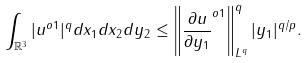Convert formula to latex. <formula><loc_0><loc_0><loc_500><loc_500>\int _ { \mathbb { R } ^ { 3 } } | u ^ { o 1 } | ^ { q } d x _ { 1 } d x _ { 2 } d y _ { 2 } \leq \left \| \frac { \partial u } { \partial y _ { 1 } } ^ { o 1 } \right \| _ { L ^ { q } } ^ { q } | y _ { 1 } | ^ { q / p } .</formula> 